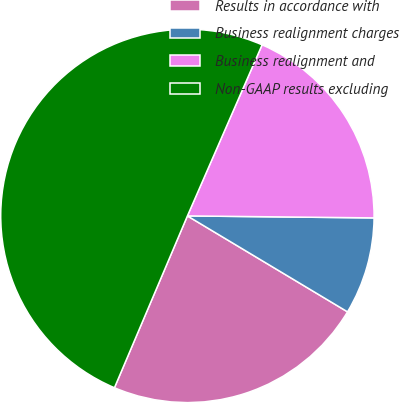Convert chart to OTSL. <chart><loc_0><loc_0><loc_500><loc_500><pie_chart><fcel>Results in accordance with<fcel>Business realignment charges<fcel>Business realignment and<fcel>Non-GAAP results excluding<nl><fcel>22.8%<fcel>8.42%<fcel>18.62%<fcel>50.16%<nl></chart> 